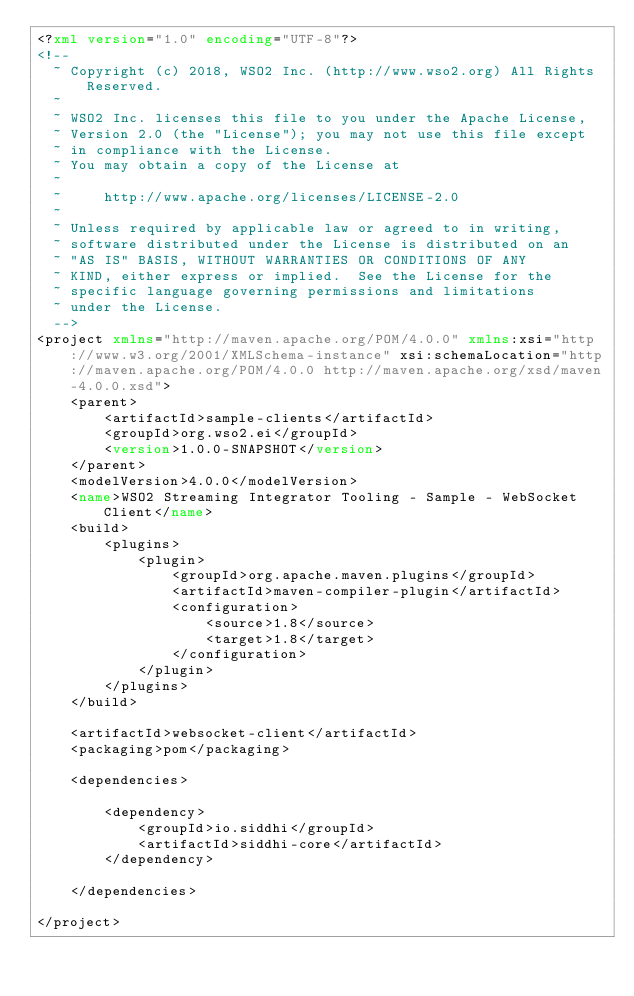Convert code to text. <code><loc_0><loc_0><loc_500><loc_500><_XML_><?xml version="1.0" encoding="UTF-8"?>
<!--
  ~ Copyright (c) 2018, WSO2 Inc. (http://www.wso2.org) All Rights Reserved.
  ~
  ~ WSO2 Inc. licenses this file to you under the Apache License,
  ~ Version 2.0 (the "License"); you may not use this file except
  ~ in compliance with the License.
  ~ You may obtain a copy of the License at
  ~
  ~     http://www.apache.org/licenses/LICENSE-2.0
  ~
  ~ Unless required by applicable law or agreed to in writing,
  ~ software distributed under the License is distributed on an
  ~ "AS IS" BASIS, WITHOUT WARRANTIES OR CONDITIONS OF ANY
  ~ KIND, either express or implied.  See the License for the
  ~ specific language governing permissions and limitations
  ~ under the License.
  -->
<project xmlns="http://maven.apache.org/POM/4.0.0" xmlns:xsi="http://www.w3.org/2001/XMLSchema-instance" xsi:schemaLocation="http://maven.apache.org/POM/4.0.0 http://maven.apache.org/xsd/maven-4.0.0.xsd">
    <parent>
        <artifactId>sample-clients</artifactId>
        <groupId>org.wso2.ei</groupId>
        <version>1.0.0-SNAPSHOT</version>
    </parent>
    <modelVersion>4.0.0</modelVersion>
    <name>WSO2 Streaming Integrator Tooling - Sample - WebSocket Client</name>
    <build>
        <plugins>
            <plugin>
                <groupId>org.apache.maven.plugins</groupId>
                <artifactId>maven-compiler-plugin</artifactId>
                <configuration>
                    <source>1.8</source>
                    <target>1.8</target>
                </configuration>
            </plugin>
        </plugins>
    </build>

    <artifactId>websocket-client</artifactId>
    <packaging>pom</packaging>

    <dependencies>

        <dependency>
            <groupId>io.siddhi</groupId>
            <artifactId>siddhi-core</artifactId>
        </dependency>

    </dependencies>

</project></code> 